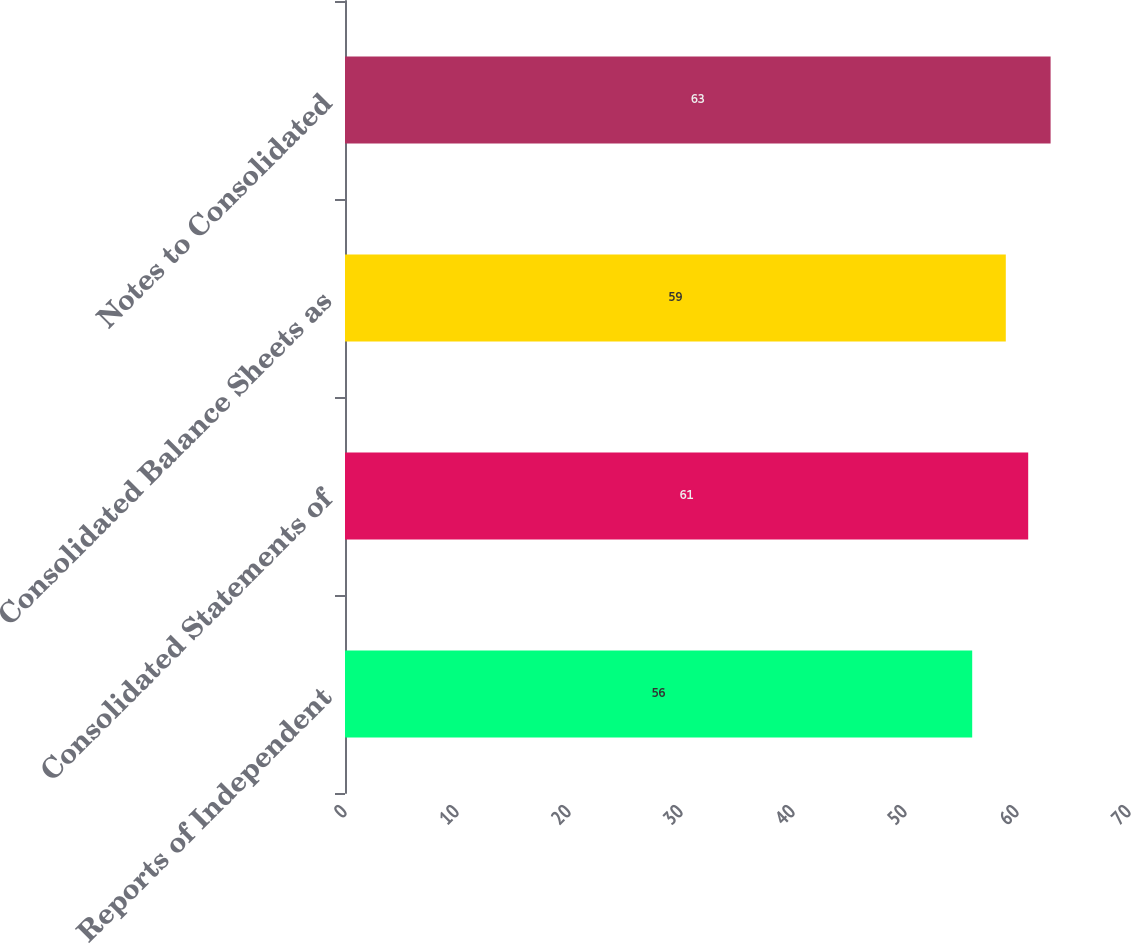Convert chart. <chart><loc_0><loc_0><loc_500><loc_500><bar_chart><fcel>Reports of Independent<fcel>Consolidated Statements of<fcel>Consolidated Balance Sheets as<fcel>Notes to Consolidated<nl><fcel>56<fcel>61<fcel>59<fcel>63<nl></chart> 